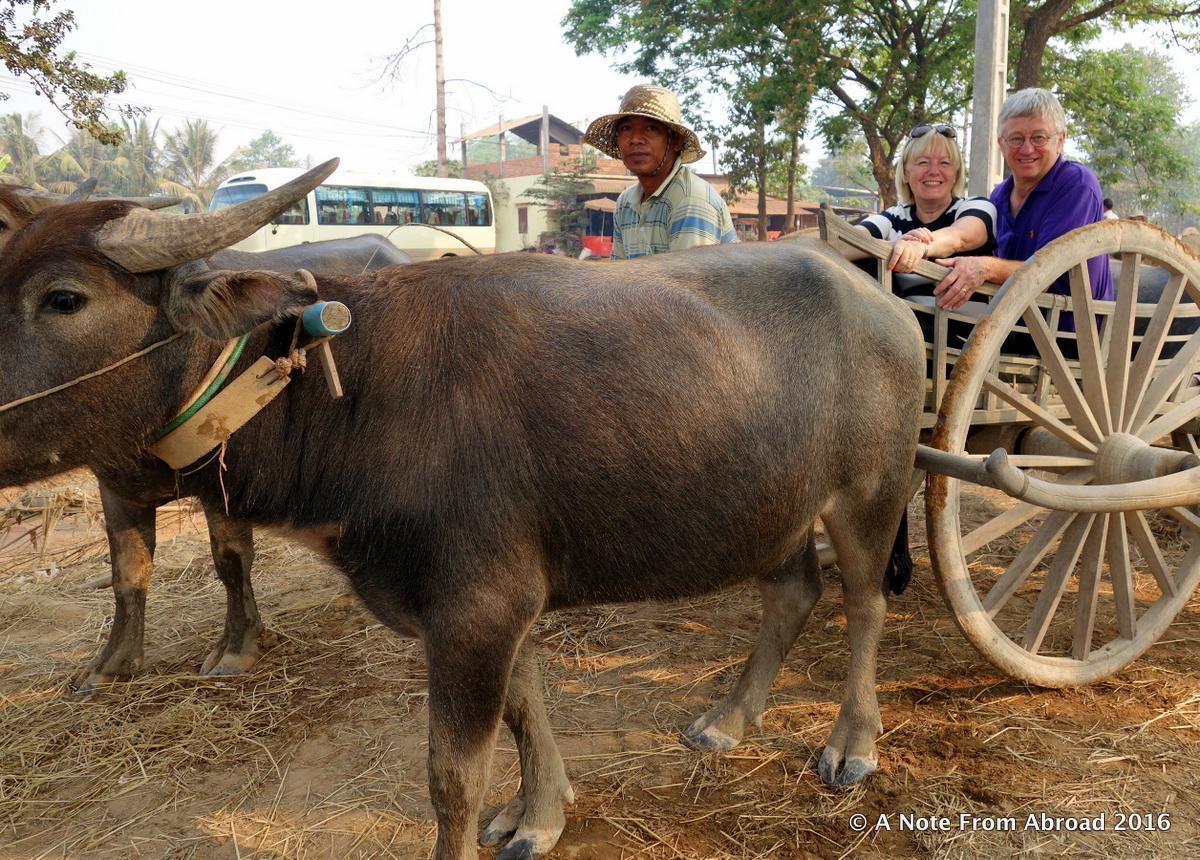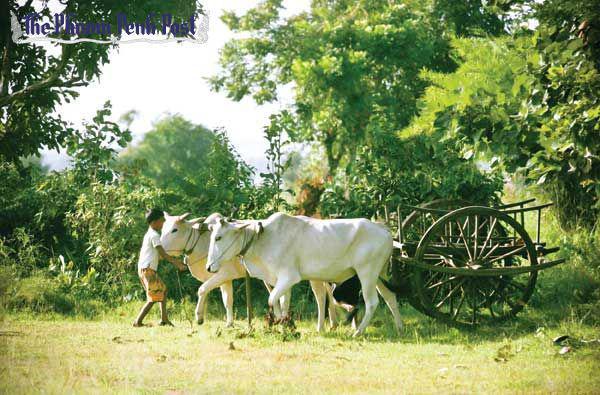The first image is the image on the left, the second image is the image on the right. Evaluate the accuracy of this statement regarding the images: "In one image, two dark oxen pull a two-wheeled cart with two passengers and a driver in a cap leftward.". Is it true? Answer yes or no. Yes. The first image is the image on the left, the second image is the image on the right. Analyze the images presented: Is the assertion "there is only one person in one of the images." valid? Answer yes or no. Yes. 